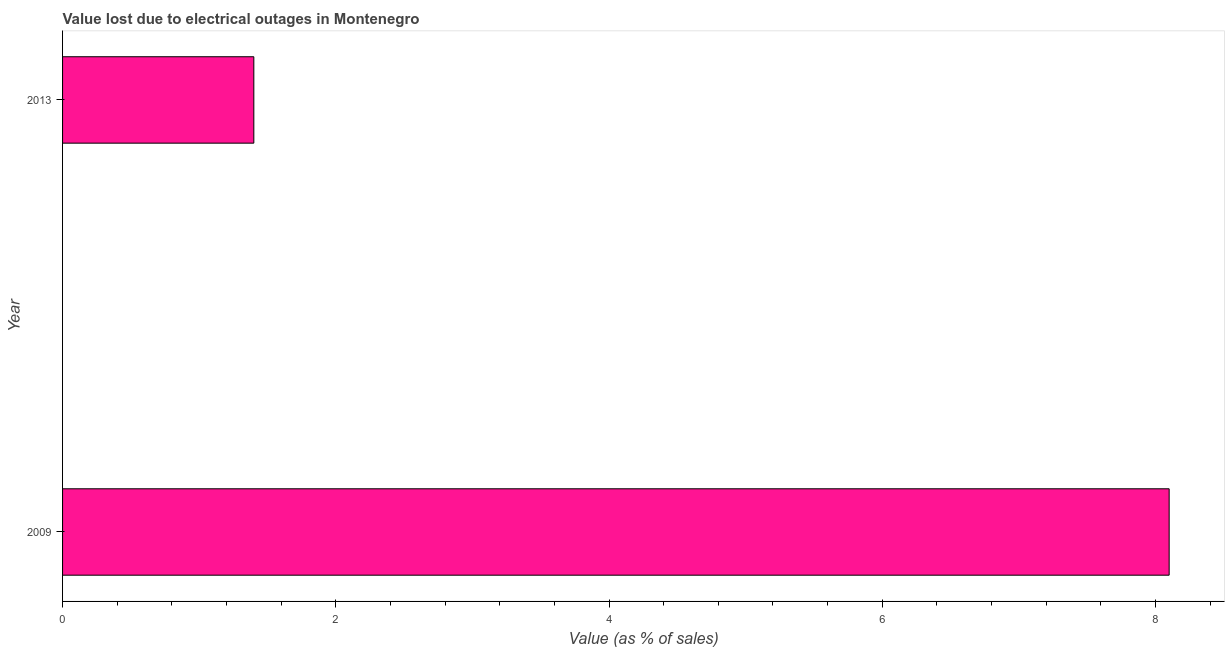What is the title of the graph?
Provide a short and direct response. Value lost due to electrical outages in Montenegro. What is the label or title of the X-axis?
Your answer should be very brief. Value (as % of sales). What is the value lost due to electrical outages in 2013?
Provide a succinct answer. 1.4. Across all years, what is the minimum value lost due to electrical outages?
Provide a short and direct response. 1.4. In which year was the value lost due to electrical outages maximum?
Give a very brief answer. 2009. In which year was the value lost due to electrical outages minimum?
Ensure brevity in your answer.  2013. What is the sum of the value lost due to electrical outages?
Keep it short and to the point. 9.5. What is the difference between the value lost due to electrical outages in 2009 and 2013?
Your answer should be very brief. 6.7. What is the average value lost due to electrical outages per year?
Offer a very short reply. 4.75. What is the median value lost due to electrical outages?
Your answer should be very brief. 4.75. In how many years, is the value lost due to electrical outages greater than 1.6 %?
Your answer should be very brief. 1. What is the ratio of the value lost due to electrical outages in 2009 to that in 2013?
Ensure brevity in your answer.  5.79. Are all the bars in the graph horizontal?
Your response must be concise. Yes. What is the difference between two consecutive major ticks on the X-axis?
Your answer should be compact. 2. Are the values on the major ticks of X-axis written in scientific E-notation?
Offer a very short reply. No. What is the difference between the Value (as % of sales) in 2009 and 2013?
Make the answer very short. 6.7. What is the ratio of the Value (as % of sales) in 2009 to that in 2013?
Ensure brevity in your answer.  5.79. 